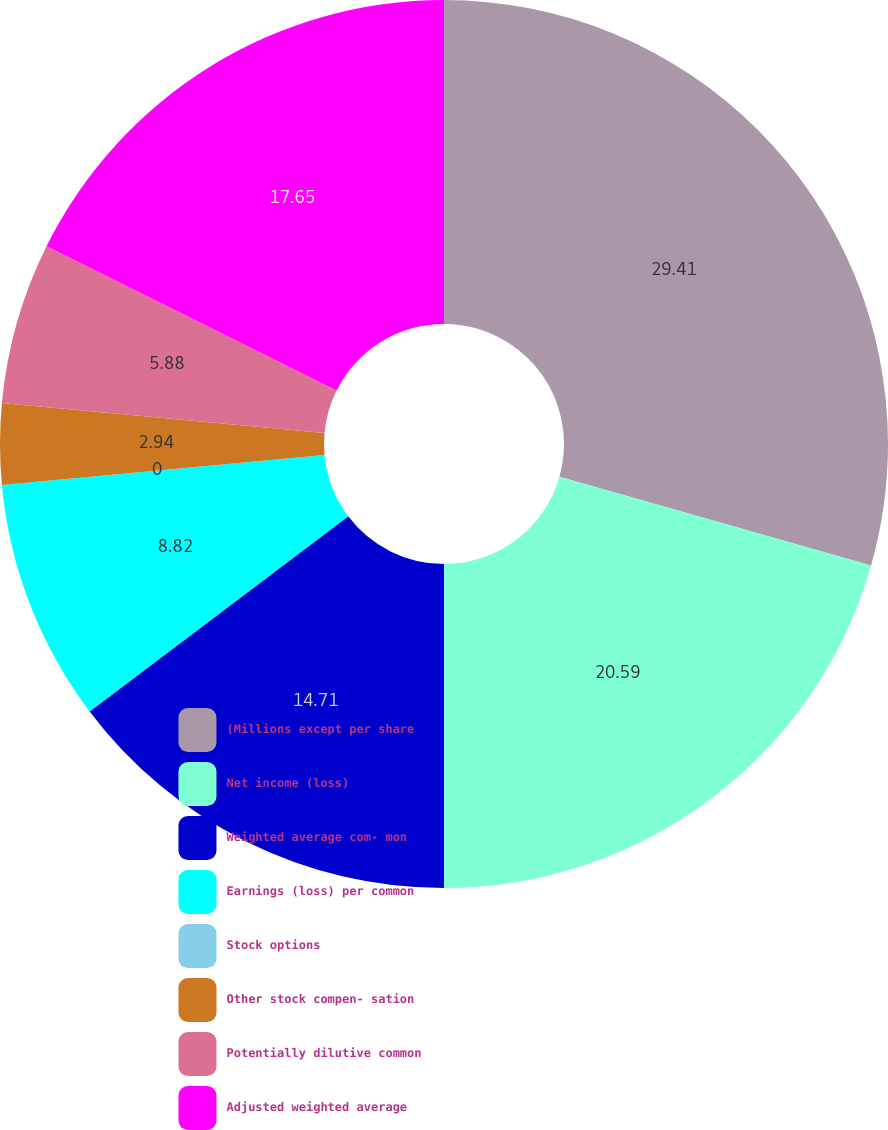Convert chart to OTSL. <chart><loc_0><loc_0><loc_500><loc_500><pie_chart><fcel>(Millions except per share<fcel>Net income (loss)<fcel>Weighted average com- mon<fcel>Earnings (loss) per common<fcel>Stock options<fcel>Other stock compen- sation<fcel>Potentially dilutive common<fcel>Adjusted weighted average<nl><fcel>29.41%<fcel>20.59%<fcel>14.71%<fcel>8.82%<fcel>0.0%<fcel>2.94%<fcel>5.88%<fcel>17.65%<nl></chart> 